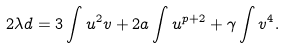Convert formula to latex. <formula><loc_0><loc_0><loc_500><loc_500>2 \lambda d = 3 \int u ^ { 2 } v + 2 a \int u ^ { p + 2 } + \gamma \int v ^ { 4 } .</formula> 